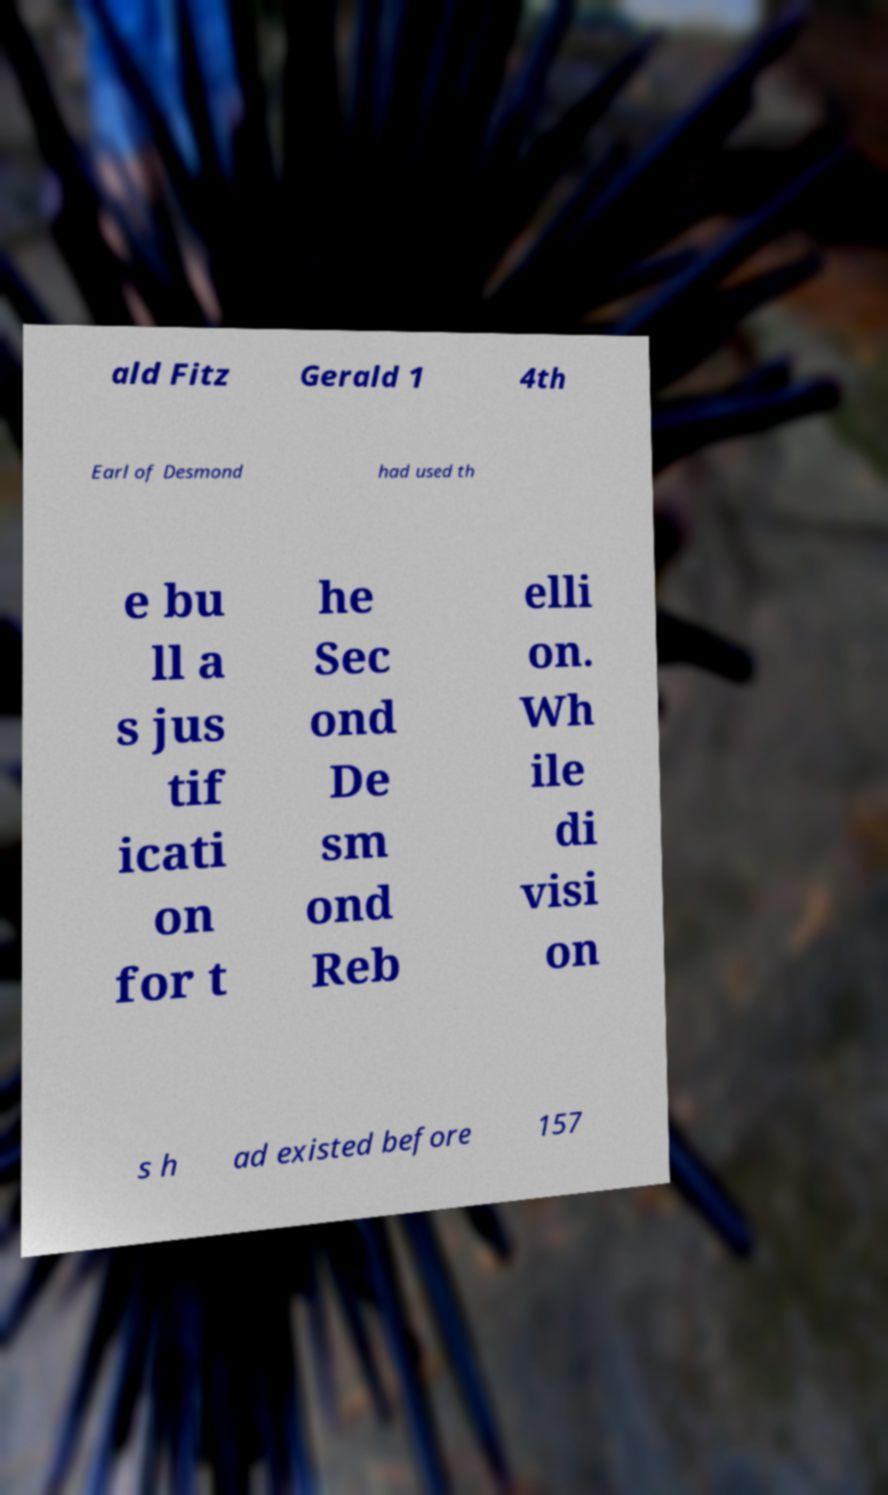What messages or text are displayed in this image? I need them in a readable, typed format. ald Fitz Gerald 1 4th Earl of Desmond had used th e bu ll a s jus tif icati on for t he Sec ond De sm ond Reb elli on. Wh ile di visi on s h ad existed before 157 